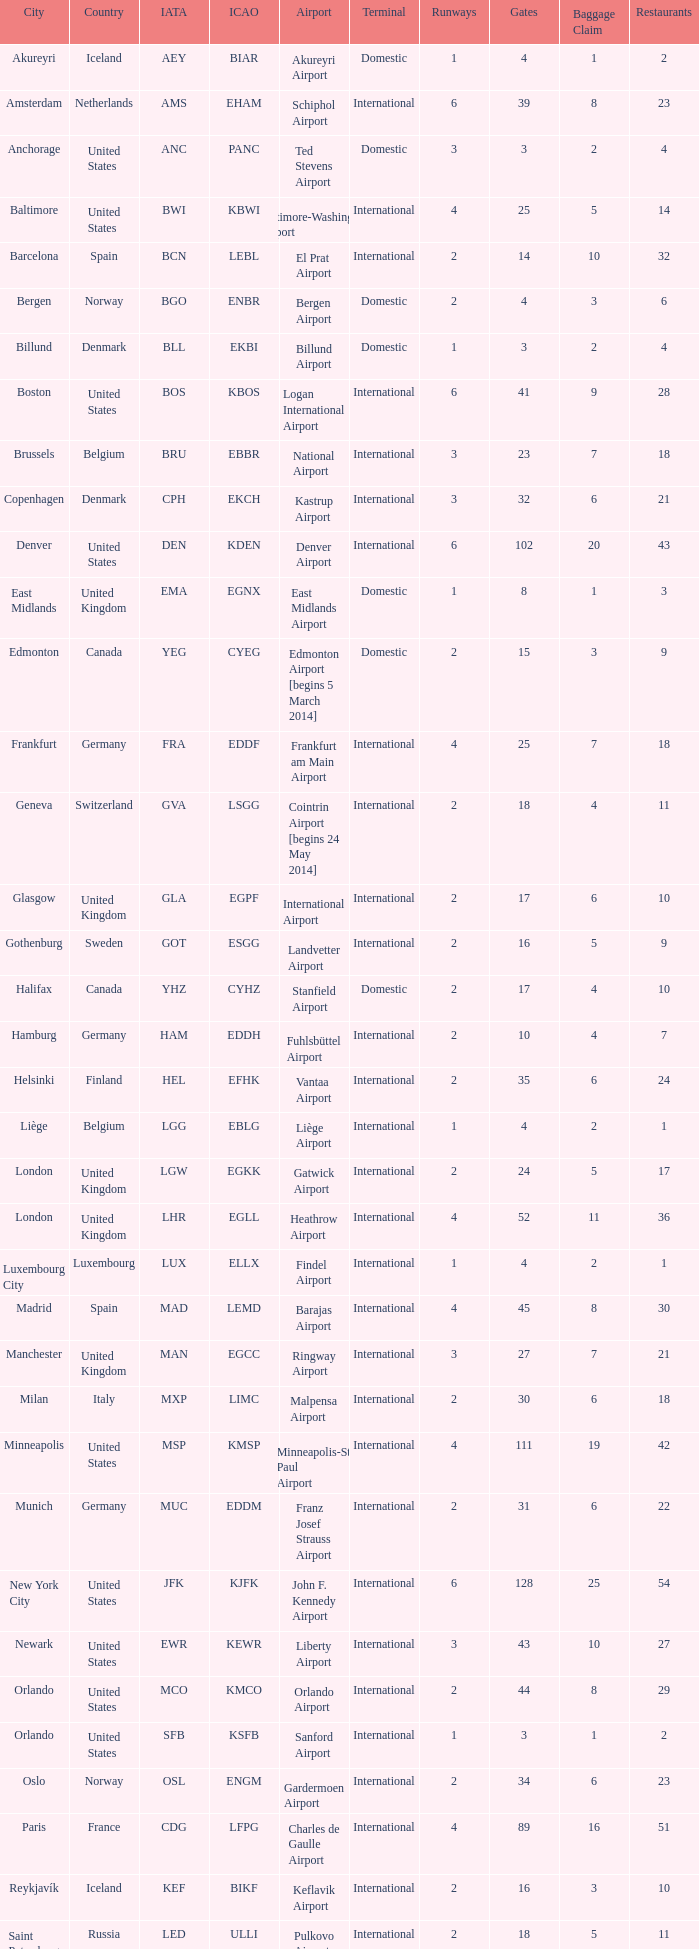What is the IATA OF Akureyri? AEY. 